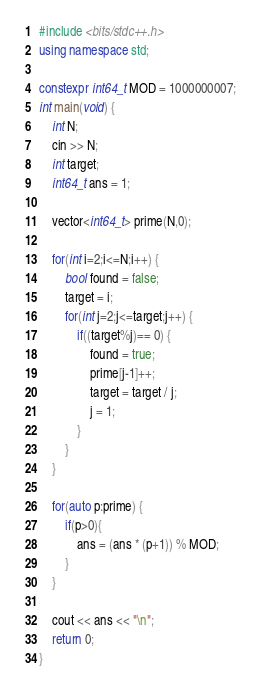<code> <loc_0><loc_0><loc_500><loc_500><_C++_>#include <bits/stdc++.h>
using namespace std;

constexpr int64_t MOD = 1000000007;
int main(void) {
    int N;
    cin >> N;
    int target;
    int64_t ans = 1;
    
    vector<int64_t> prime(N,0);

    for(int i=2;i<=N;i++) {
        bool found = false;
        target = i;
        for(int j=2;j<=target;j++) {
            if((target%j)== 0) {
                found = true;
                prime[j-1]++;
                target = target / j;
                j = 1;
            }
        }
    }

    for(auto p:prime) {
        if(p>0){
            ans = (ans * (p+1)) % MOD;
        }
    }

    cout << ans << "\n";
    return 0;
}
</code> 